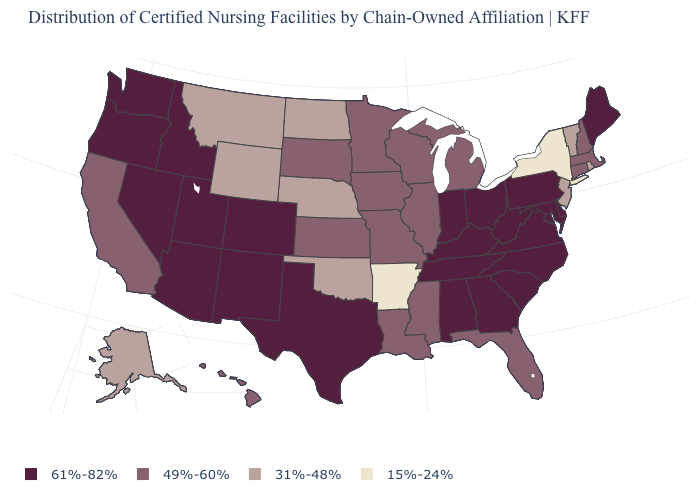What is the value of North Carolina?
Give a very brief answer. 61%-82%. Is the legend a continuous bar?
Concise answer only. No. What is the value of New Hampshire?
Short answer required. 49%-60%. Does the first symbol in the legend represent the smallest category?
Keep it brief. No. What is the value of New Hampshire?
Write a very short answer. 49%-60%. Name the states that have a value in the range 61%-82%?
Write a very short answer. Alabama, Arizona, Colorado, Delaware, Georgia, Idaho, Indiana, Kentucky, Maine, Maryland, Nevada, New Mexico, North Carolina, Ohio, Oregon, Pennsylvania, South Carolina, Tennessee, Texas, Utah, Virginia, Washington, West Virginia. Name the states that have a value in the range 15%-24%?
Give a very brief answer. Arkansas, New York. Which states have the lowest value in the Northeast?
Keep it brief. New York. Among the states that border Utah , which have the highest value?
Write a very short answer. Arizona, Colorado, Idaho, Nevada, New Mexico. What is the value of West Virginia?
Short answer required. 61%-82%. What is the value of Rhode Island?
Give a very brief answer. 31%-48%. Name the states that have a value in the range 15%-24%?
Give a very brief answer. Arkansas, New York. Is the legend a continuous bar?
Short answer required. No. Does Alaska have the lowest value in the USA?
Give a very brief answer. No. 